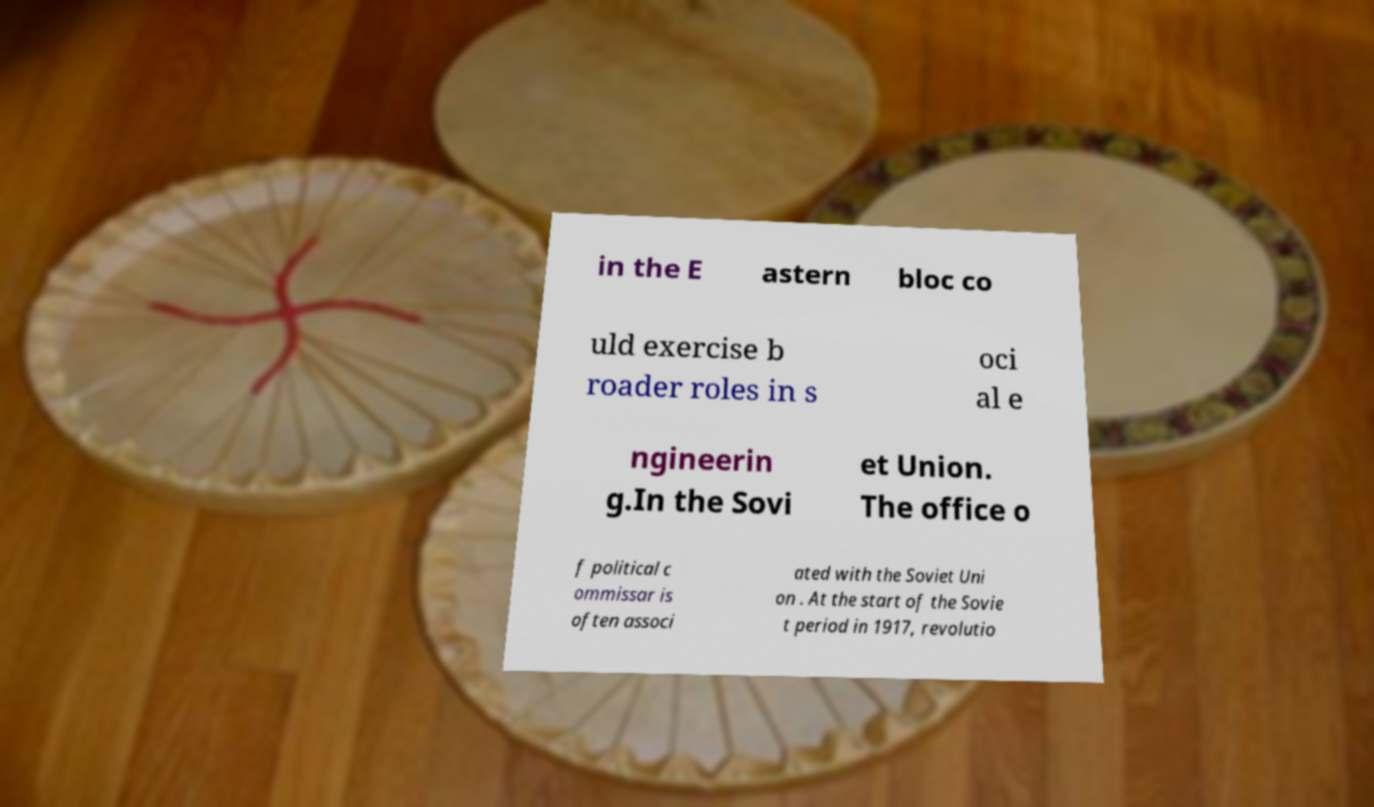I need the written content from this picture converted into text. Can you do that? in the E astern bloc co uld exercise b roader roles in s oci al e ngineerin g.In the Sovi et Union. The office o f political c ommissar is often associ ated with the Soviet Uni on . At the start of the Sovie t period in 1917, revolutio 